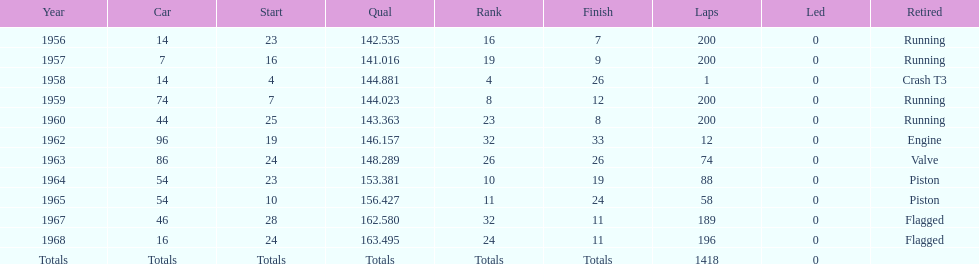Did bob veith drive more indy 500 laps in the 1950s or 1960s? 1960s. 